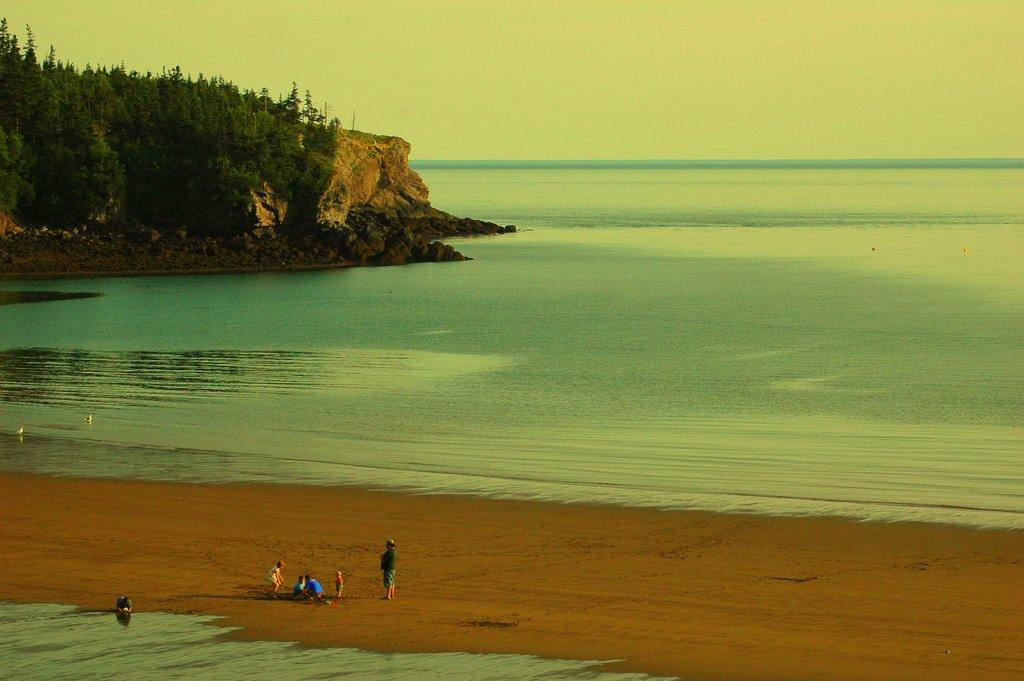Who is present in the image? There is a person and children in the image. What are the people wearing? The people are wearing clothes. Where does the scene appear to take place? The scene appears to be at a beach. What natural elements can be seen in the image? There are trees, rocks, water, and the sky visible in the image. What type of orange tree can be seen in the image? There is no orange tree present in the image. How many hills are visible in the image? There are no hills visible in the image. 